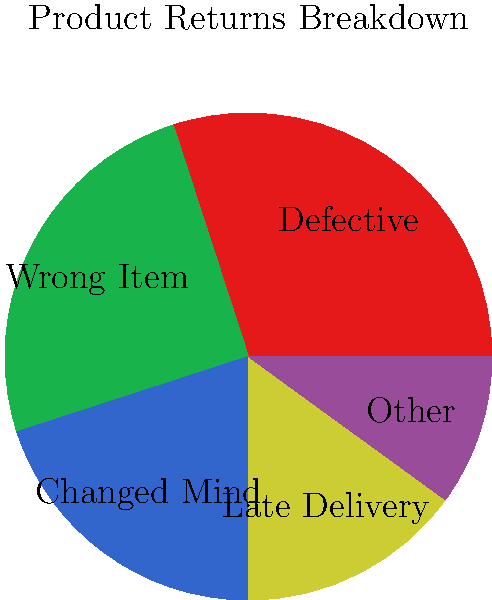As a seller providing insider tips, you've obtained a pie chart showing the breakdown of product returns for a major e-commerce platform. Which two reasons for returns, when combined, account for more than half of all returns, and what does this suggest about potential unethical practices in the industry? To answer this question, let's analyze the pie chart step-by-step:

1. The pie chart shows five categories of product returns:
   - Defective: 30%
   - Wrong Item: 25%
   - Changed Mind: 20%
   - Late Delivery: 15%
   - Other: 10%

2. To find which two reasons account for more than 50% of returns, we need to identify the two largest segments:
   - Defective (30%)
   - Wrong Item (25%)

3. Combined percentage: 30% + 25% = 55%

4. These two reasons indeed account for more than half of all returns.

5. Analyzing the implications:
   - The high percentage of "Defective" items (30%) suggests potential quality control issues or the possibility of sellers knowingly shipping faulty products.
   - "Wrong Item" being the second-highest category (25%) could indicate inventory mismanagement, deliberate bait-and-switch tactics, or inadequate order fulfillment processes.

6. Potential unethical practices:
   - Some sellers might be cutting corners on quality control to reduce costs, leading to a high rate of defective items.
   - There could be intentional misrepresentation of products, where sellers ship cheaper alternatives instead of the advertised items.
   - The combination of these two issues suggests a systemic problem in the industry, where some sellers prioritize short-term profits over customer satisfaction and ethical business practices.
Answer: Defective (30%) and Wrong Item (25%), totaling 55%. This suggests potential quality control issues and deliberate misrepresentation of products by some sellers. 